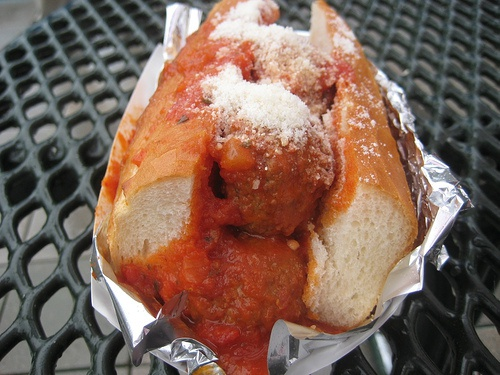Describe the objects in this image and their specific colors. I can see hot dog in gray, maroon, brown, and tan tones and sandwich in gray, maroon, brown, and tan tones in this image. 